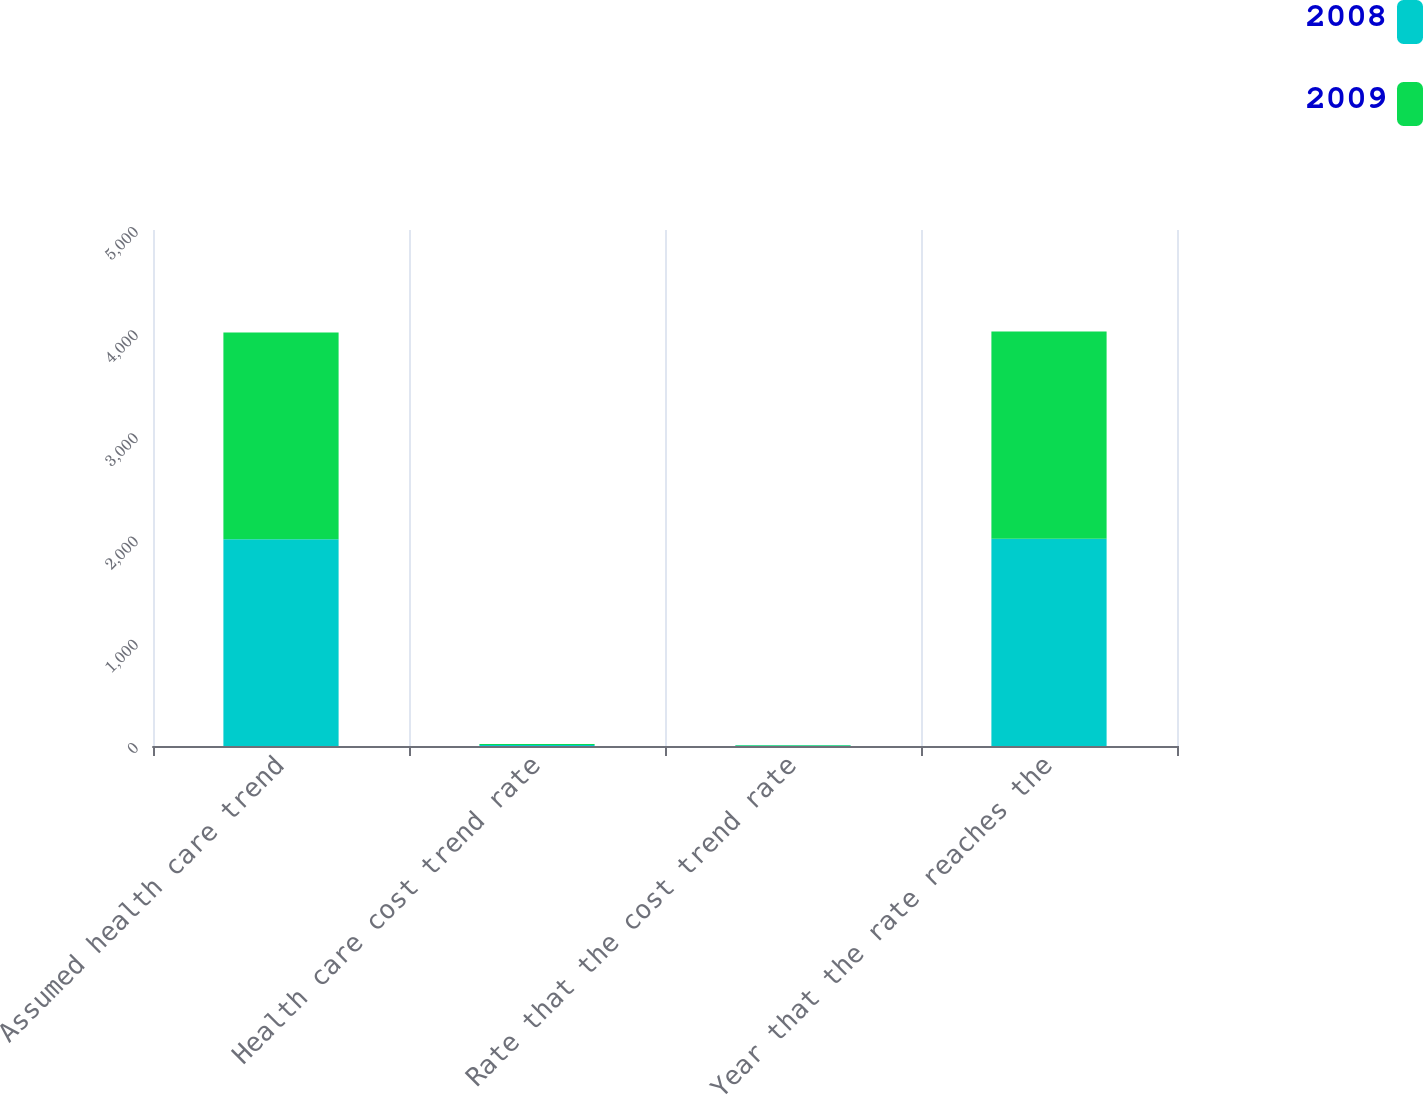Convert chart. <chart><loc_0><loc_0><loc_500><loc_500><stacked_bar_chart><ecel><fcel>Assumed health care trend<fcel>Health care cost trend rate<fcel>Rate that the cost trend rate<fcel>Year that the rate reaches the<nl><fcel>2008<fcel>2004<fcel>10<fcel>5<fcel>2009<nl><fcel>2009<fcel>2003<fcel>10<fcel>5<fcel>2008<nl></chart> 